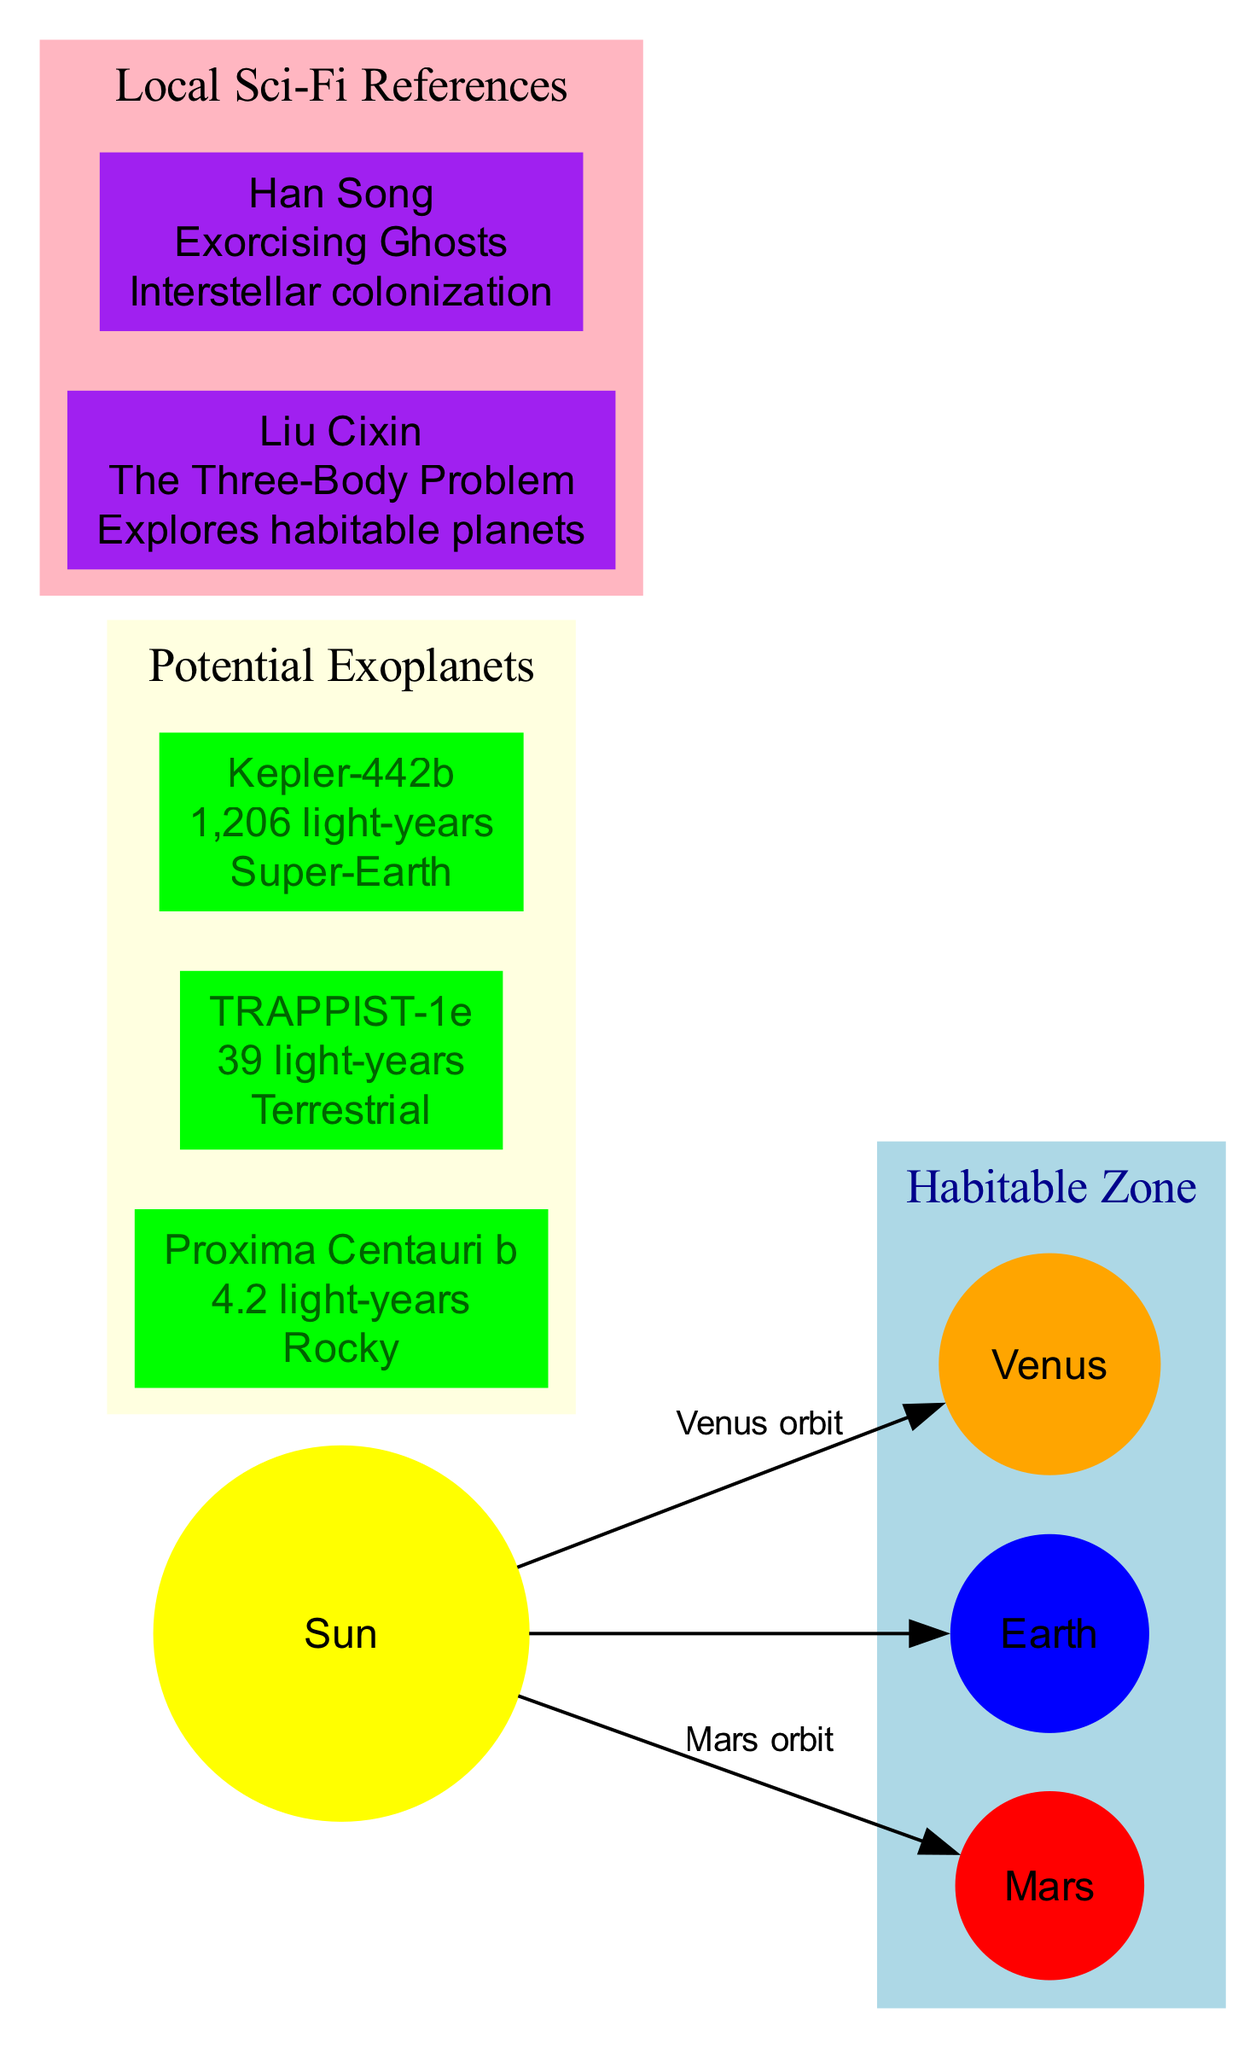What is the inner boundary of the habitable zone? The inner boundary of the habitable zone is labeled as "Venus orbit" in the diagram, indicating the closest point within the habitable zone around the Sun.
Answer: Venus orbit How many potential exoplanets are highlighted in the diagram? The diagram lists three potential exoplanets: Proxima Centauri b, TRAPPIST-1e, and Kepler-442b. Thus, the total number of exoplanets is obtained by counting these nodes.
Answer: 3 What is the distance of TRAPPIST-1e from the Sun? The diagram shows that TRAPPIST-1e is 39 light-years away from the Sun as labeled in the node representing this exoplanet.
Answer: 39 light-years What type of planet is Kepler-442b classified as? In the diagram, Kepler-442b is categorized under the potential exoplanets section, where it is marked "Super-Earth," indicating its classification.
Answer: Super-Earth Which planet is positioned at the outer boundary of the habitable zone? The outer boundary of the habitable zone is connected to the "Mars" node, indicating that Mars defines the farthest extent of the habitable zone around the Sun.
Answer: Mars Who is the author of "The Three-Body Problem"? The diagram includes a node that identifies Liu Cixin as the author of the book "The Three-Body Problem," providing a direct association between the author and the title.
Answer: Liu Cixin What relevance does the book "Exorcising Ghosts" have? The diagram specifies that "Exorcising Ghosts," authored by Han Song, relates to interstellar colonization, providing context about its thematic relevance in the sci-fi genre.
Answer: Interstellar colonization What color is the habitable zone represented in the diagram? The habitable zone is visually represented in light blue color, as indicated in its labeled section within the diagram.
Answer: Light blue How far is Proxima Centauri b from the Sun? The diagram details that Proxima Centauri b is situated 4.2 light-years away from the Sun, providing a clear measurement of distance.
Answer: 4.2 light-years 